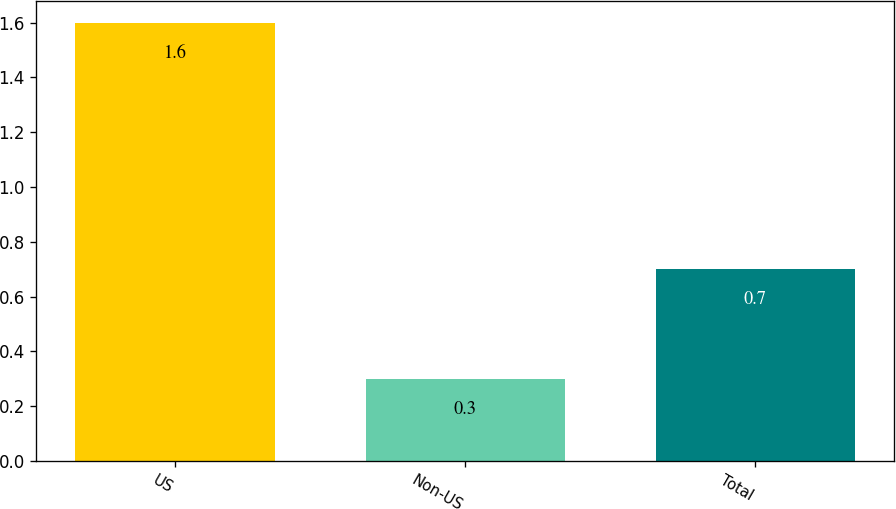<chart> <loc_0><loc_0><loc_500><loc_500><bar_chart><fcel>US<fcel>Non-US<fcel>Total<nl><fcel>1.6<fcel>0.3<fcel>0.7<nl></chart> 